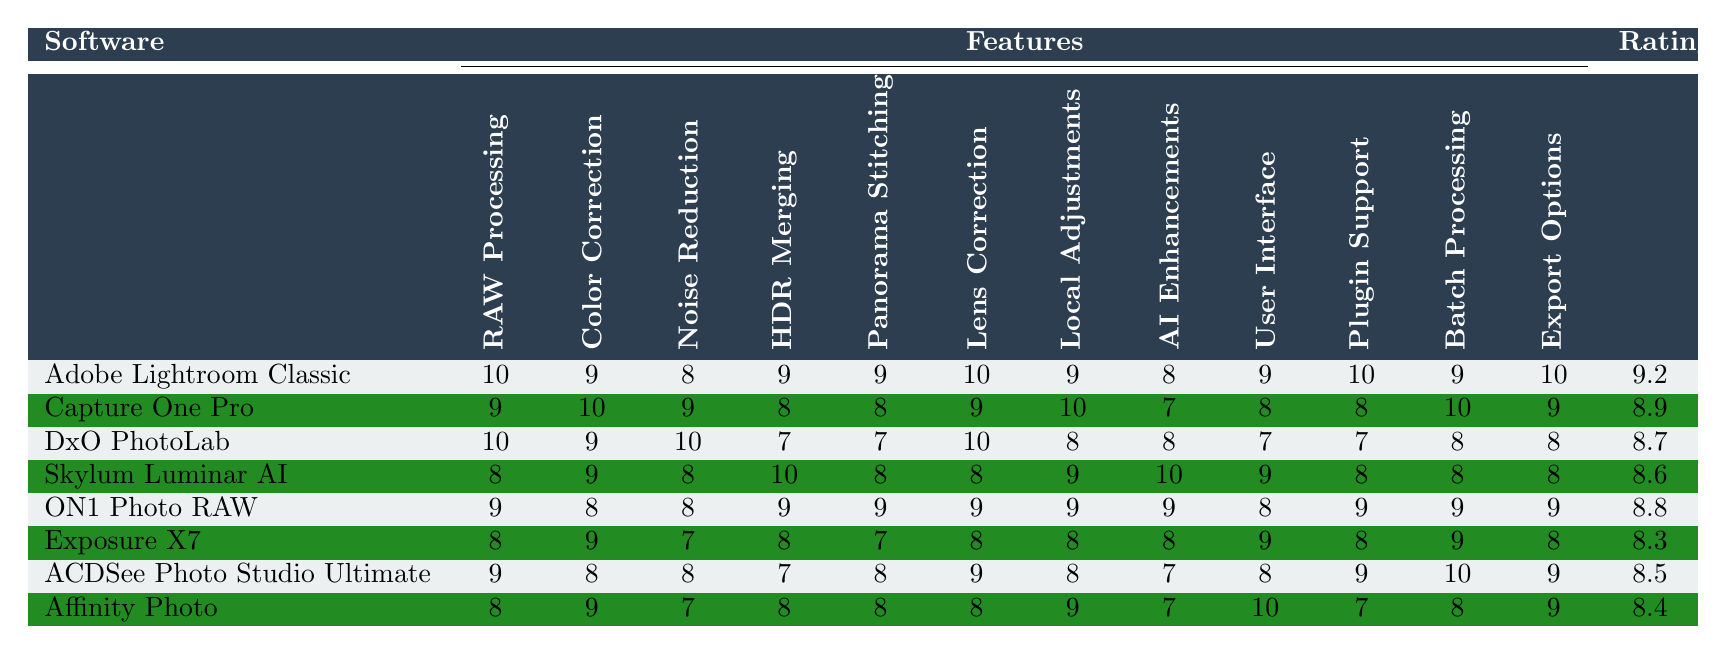What software has the highest rating for RAW Processing? Adobe Lightroom Classic is rated 10 for RAW Processing, which is the highest score among all the software listed in the table.
Answer: Adobe Lightroom Classic Which software has the lowest score in Noise Reduction? Exposure X7 and Affinity Photo both have a score of 7 in Noise Reduction, making them the lowest among the options.
Answer: Exposure X7 and Affinity Photo What is the overall user rating of DxO PhotoLab? The overall user rating for DxO PhotoLab is 8.7, as indicated in the last column of the table.
Answer: 8.7 Which software provides the best Color Correction feature? Capture One Pro has the highest score of 10 for Color Correction, making it the best in this feature category.
Answer: Capture One Pro Is it true that Affinity Photo has the highest score for User Interface? Yes, Affinity Photo scores 10 for User Interface, which is the highest among all the software in this category.
Answer: Yes What are the average scores for HDR Merging across all software? The scores for HDR Merging are 9, 8, 7, 10, 9, 8, 7, and 8. Summing these values gives 66, and dividing by the 8 software produces an average of 8.25.
Answer: 8.25 Which software has a score of 8 in Batch Processing? Exposure X7 and Skylum Luminar AI both have a score of 8 in Batch Processing according to the table.
Answer: Exposure X7 and Skylum Luminar AI What is the difference in Overall User Rating between Adobe Lightroom Classic and Exposure X7? Adobe Lightroom Classic's rating is 9.2, while Exposure X7's is 8.3. The difference is 9.2 - 8.3, which equals 0.9.
Answer: 0.9 What feature did Skylum Luminar AI score the highest in? Skylum Luminar AI scored the highest in AI-powered Enhancements with a score of 10.
Answer: AI-powered Enhancements Which software has the most variation in features based on their ratings? After analyzing the scores, DxO PhotoLab exhibits the most variation, with scores ranging from 10 to 7 across its features, indicating inconsistent feature performance.
Answer: DxO PhotoLab 